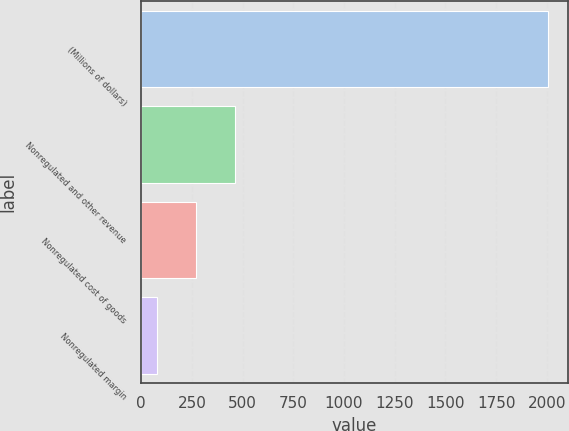Convert chart to OTSL. <chart><loc_0><loc_0><loc_500><loc_500><bar_chart><fcel>(Millions of dollars)<fcel>Nonregulated and other revenue<fcel>Nonregulated cost of goods<fcel>Nonregulated margin<nl><fcel>2004<fcel>463.2<fcel>270.6<fcel>78<nl></chart> 